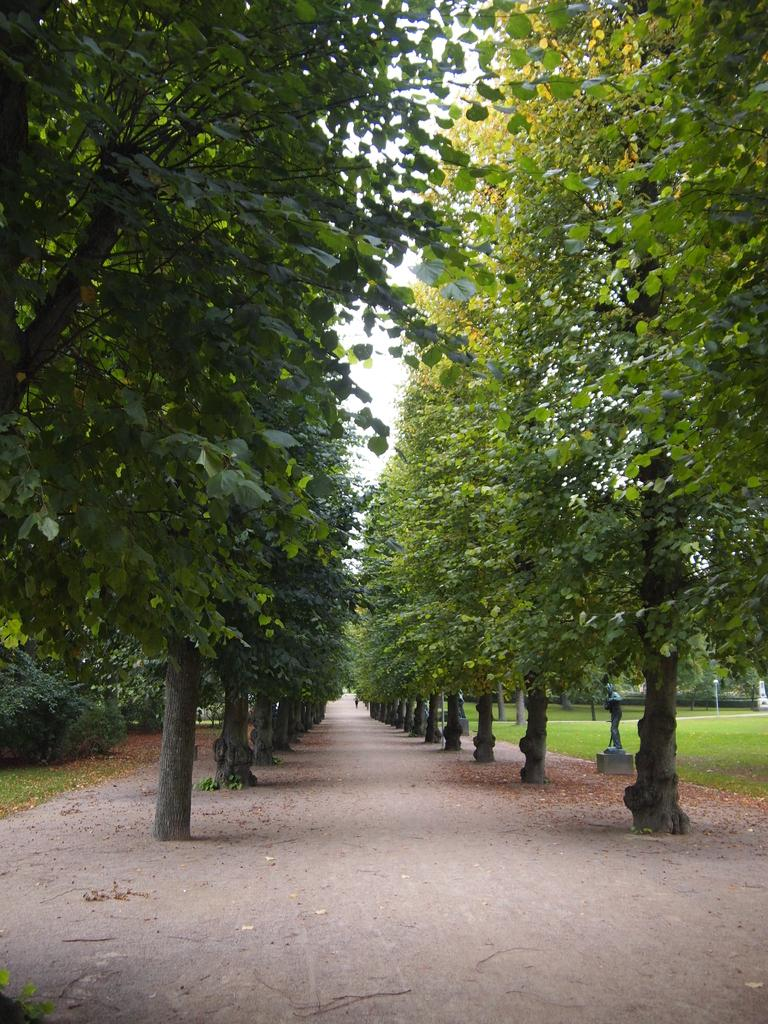What type of vegetation is present on the ground in the image? There are trees on the ground in the image. What can be seen on the right side of the image? There is a statue on the right side of the image. What type of ground cover is visible in the image? There is grass in the image. What is visible in the background of the image? The sky is visible in the background of the image. How many bikes are parked near the statue in the image? There are no bikes present in the image. What type of property is the statue located on in the image? There is no information about the property in the image, as it only shows the statue and the surrounding environment. 